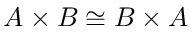Convert formula to latex. <formula><loc_0><loc_0><loc_500><loc_500>A \times B \cong B \times A</formula> 